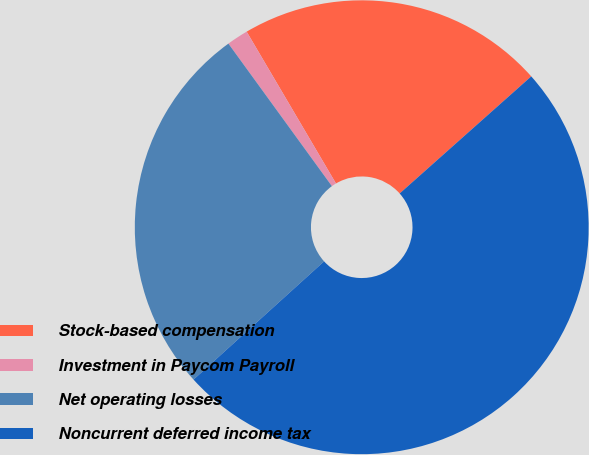Convert chart. <chart><loc_0><loc_0><loc_500><loc_500><pie_chart><fcel>Stock-based compensation<fcel>Investment in Paycom Payroll<fcel>Net operating losses<fcel>Noncurrent deferred income tax<nl><fcel>21.89%<fcel>1.53%<fcel>26.72%<fcel>49.86%<nl></chart> 